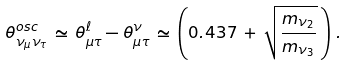Convert formula to latex. <formula><loc_0><loc_0><loc_500><loc_500>\theta _ { \nu _ { \mu } \nu _ { \tau } } ^ { o s c } \, \simeq \, \theta _ { \mu \tau } ^ { \ell } - \theta _ { \mu \tau } ^ { \nu } \, \simeq \, \left ( 0 . 4 3 7 \, + \, \sqrt { \frac { m _ { \nu _ { 2 } } } { m _ { \nu _ { 3 } } } } \, \right ) \, .</formula> 